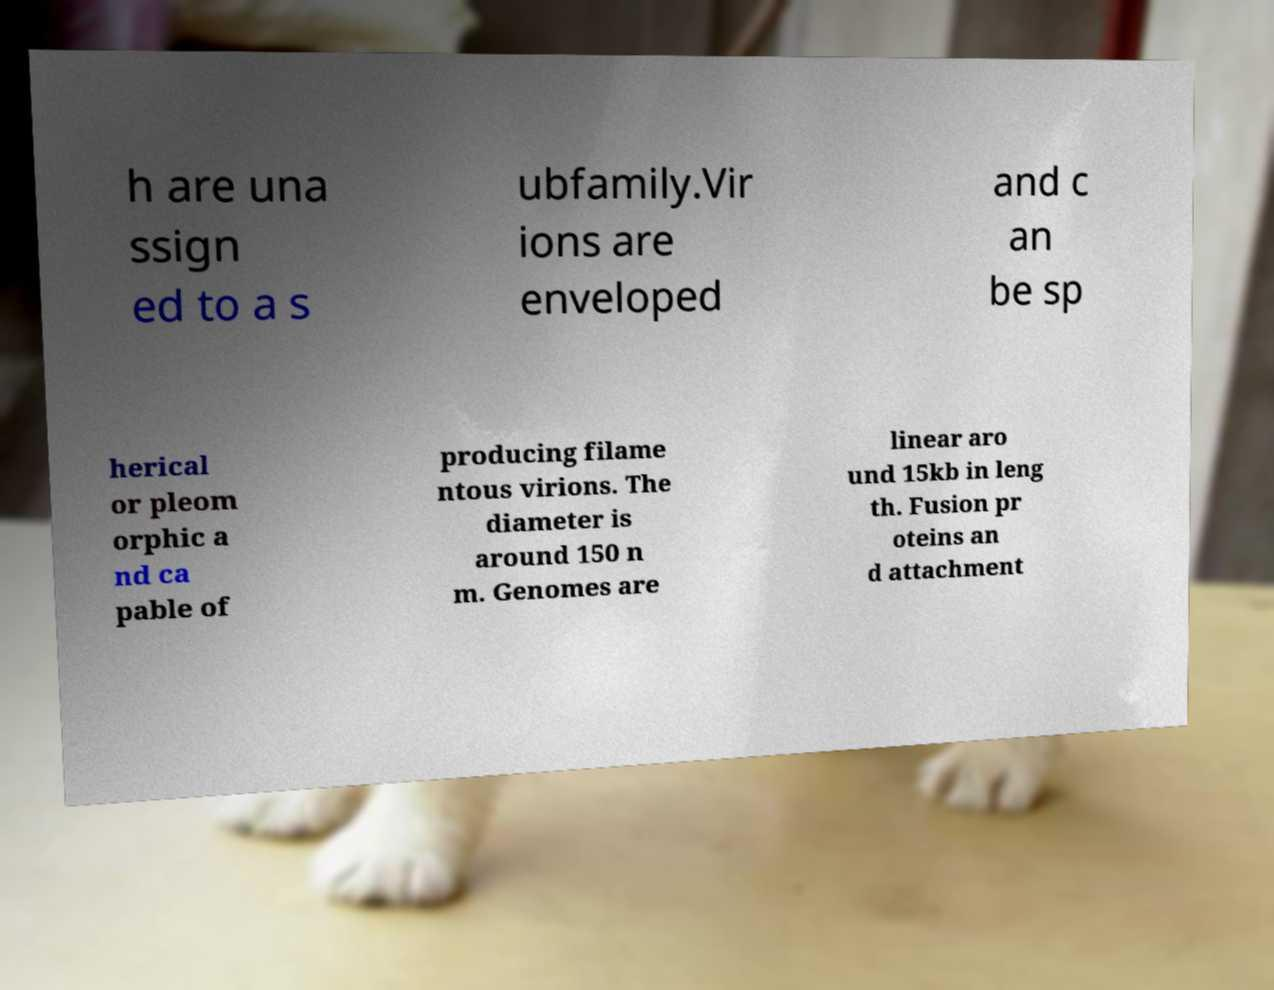What messages or text are displayed in this image? I need them in a readable, typed format. h are una ssign ed to a s ubfamily.Vir ions are enveloped and c an be sp herical or pleom orphic a nd ca pable of producing filame ntous virions. The diameter is around 150 n m. Genomes are linear aro und 15kb in leng th. Fusion pr oteins an d attachment 